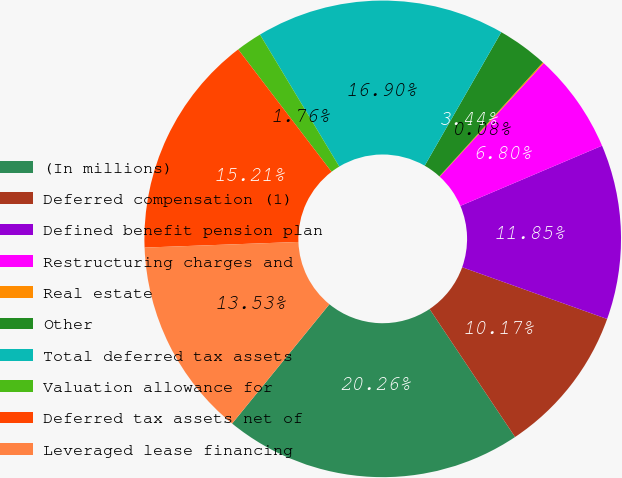Convert chart. <chart><loc_0><loc_0><loc_500><loc_500><pie_chart><fcel>(In millions)<fcel>Deferred compensation (1)<fcel>Defined benefit pension plan<fcel>Restructuring charges and<fcel>Real estate<fcel>Other<fcel>Total deferred tax assets<fcel>Valuation allowance for<fcel>Deferred tax assets net of<fcel>Leveraged lease financing<nl><fcel>20.26%<fcel>10.17%<fcel>11.85%<fcel>6.8%<fcel>0.08%<fcel>3.44%<fcel>16.9%<fcel>1.76%<fcel>15.21%<fcel>13.53%<nl></chart> 